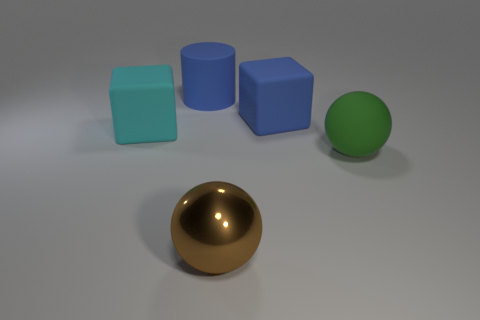Is the number of brown metal balls greater than the number of cyan cylinders?
Give a very brief answer. Yes. What is the size of the rubber object that is in front of the block to the left of the big rubber block on the right side of the big brown ball?
Your response must be concise. Large. Is the size of the green matte ball the same as the sphere in front of the big green rubber object?
Provide a succinct answer. Yes. Is the number of blue blocks behind the big blue matte cylinder less than the number of large blue shiny cylinders?
Ensure brevity in your answer.  No. What number of cubes are the same color as the big matte cylinder?
Your answer should be compact. 1. Is the number of large matte blocks less than the number of green cubes?
Offer a very short reply. No. Does the cyan thing have the same material as the big brown sphere?
Your answer should be compact. No. How many other objects are there of the same size as the metallic sphere?
Give a very brief answer. 4. The ball on the right side of the brown thing that is to the left of the blue cube is what color?
Your answer should be compact. Green. Are there any tiny gray blocks that have the same material as the cylinder?
Offer a terse response. No. 